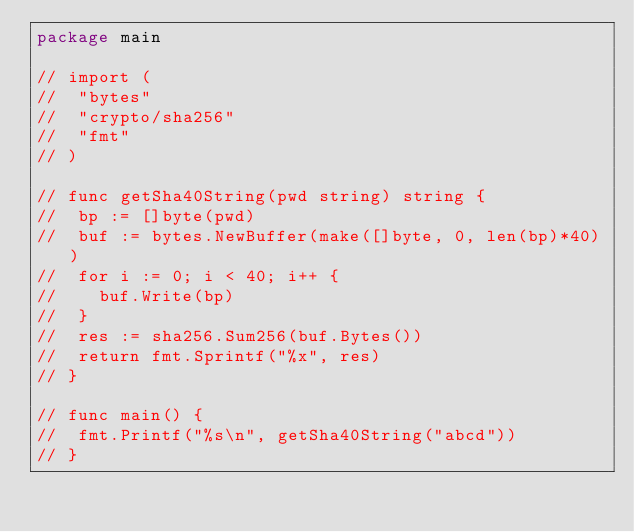<code> <loc_0><loc_0><loc_500><loc_500><_Go_>package main

// import (
// 	"bytes"
// 	"crypto/sha256"
// 	"fmt"
// )

// func getSha40String(pwd string) string {
// 	bp := []byte(pwd)
// 	buf := bytes.NewBuffer(make([]byte, 0, len(bp)*40))
// 	for i := 0; i < 40; i++ {
// 		buf.Write(bp)
// 	}
// 	res := sha256.Sum256(buf.Bytes())
// 	return fmt.Sprintf("%x", res)
// }

// func main() {
// 	fmt.Printf("%s\n", getSha40String("abcd"))
// }
</code> 